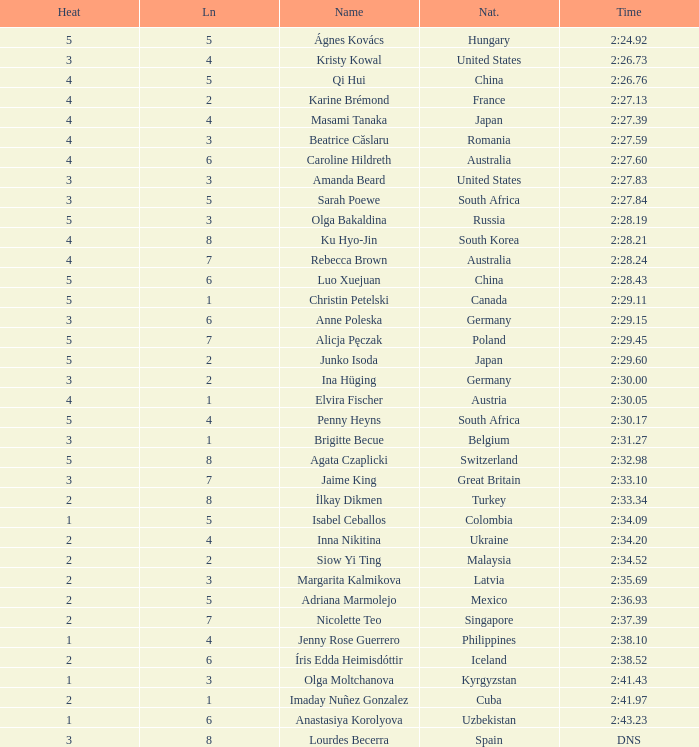What lane did inna nikitina have? 4.0. 